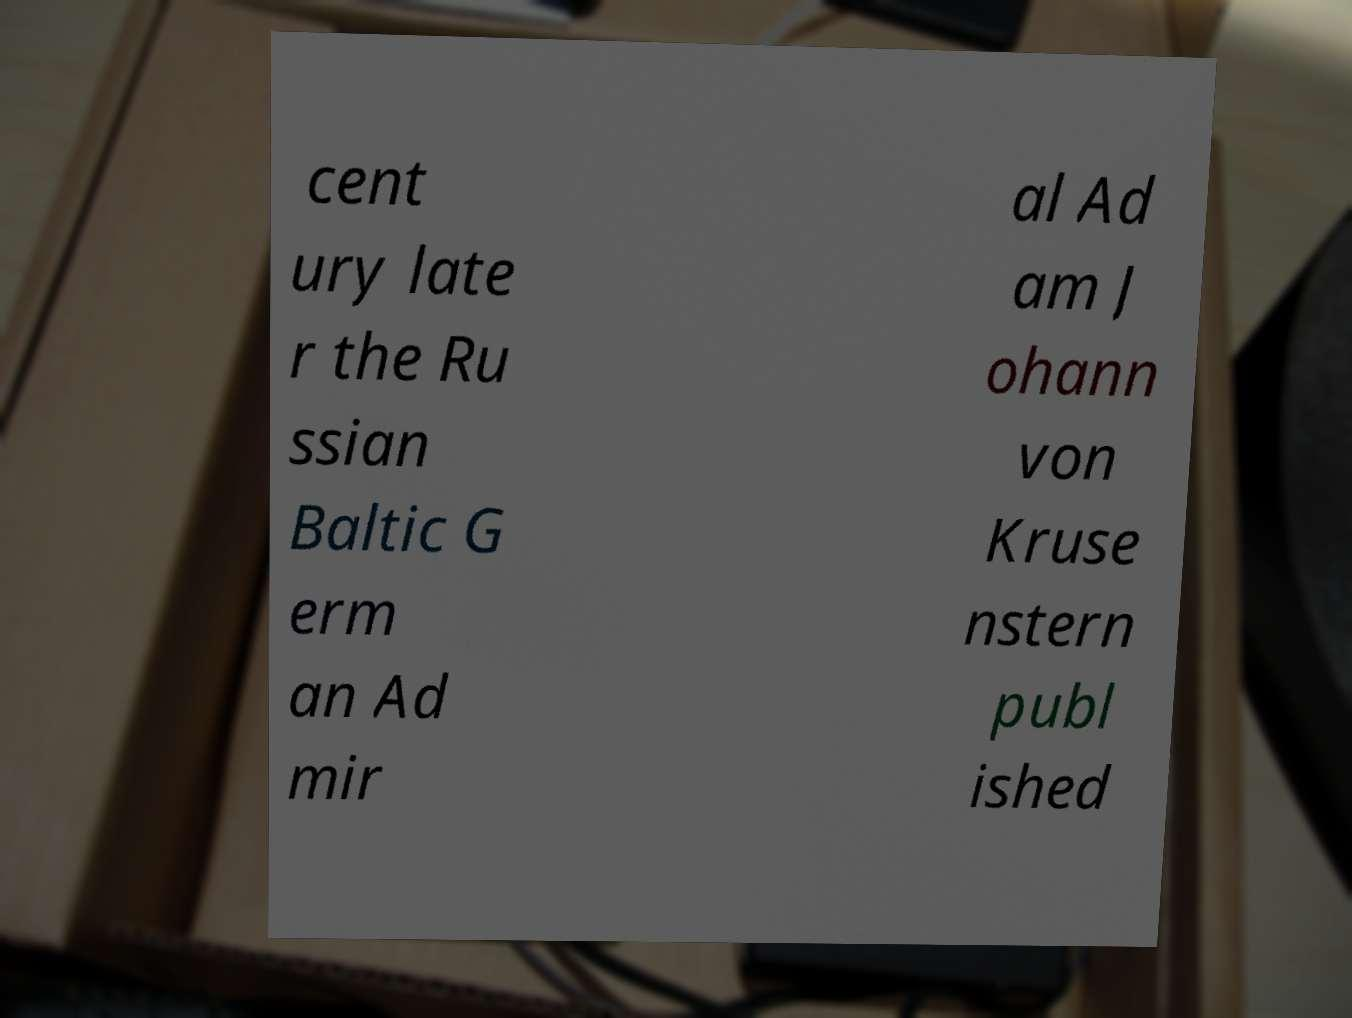Could you extract and type out the text from this image? cent ury late r the Ru ssian Baltic G erm an Ad mir al Ad am J ohann von Kruse nstern publ ished 